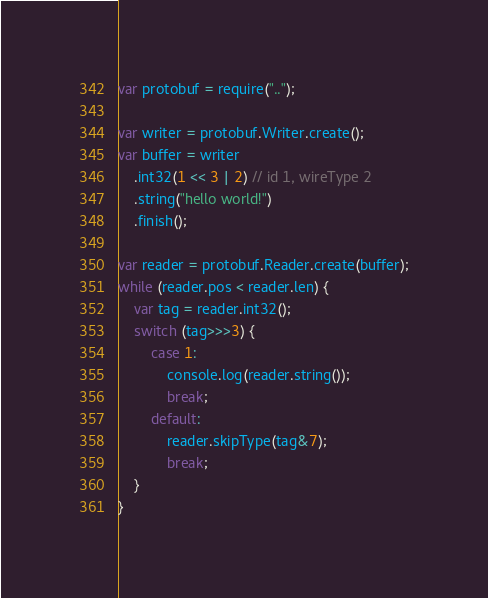Convert code to text. <code><loc_0><loc_0><loc_500><loc_500><_JavaScript_>var protobuf = require("..");

var writer = protobuf.Writer.create();
var buffer = writer
    .int32(1 << 3 | 2) // id 1, wireType 2
    .string("hello world!")
    .finish();

var reader = protobuf.Reader.create(buffer);
while (reader.pos < reader.len) {
    var tag = reader.int32();
    switch (tag>>>3) {
        case 1:
            console.log(reader.string());
            break;
        default:
            reader.skipType(tag&7);
            break;
    }
}</code> 